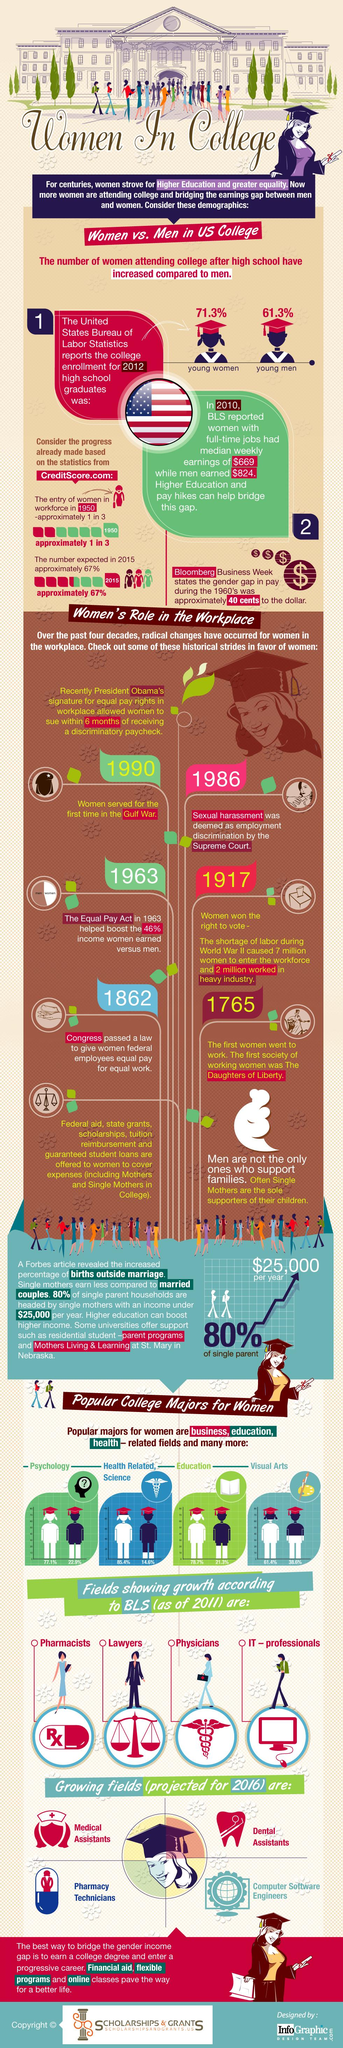Point out several critical features in this image. In 1990, women served for the first time in the Gulf War. In the year 1765, the first women began working. In 1862, Congress passed a law that granted equal pay to women federal employees for equal work. 